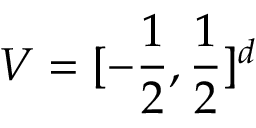<formula> <loc_0><loc_0><loc_500><loc_500>V = [ - \frac { 1 } { 2 } , \frac { 1 } { 2 } ] ^ { d }</formula> 